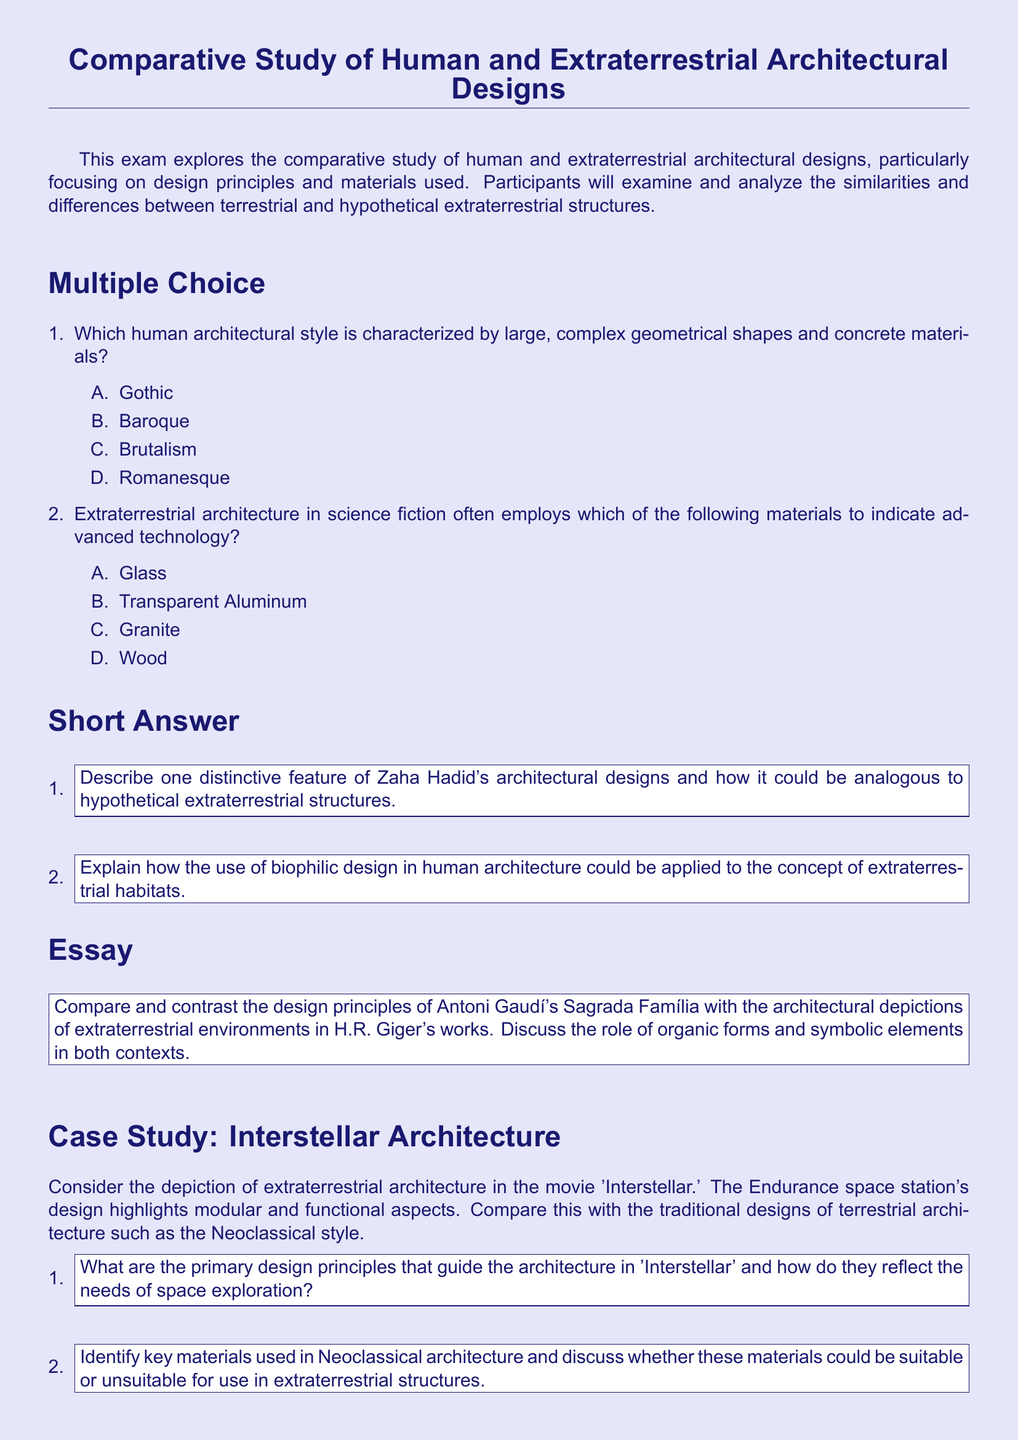What is the main focus of the exam? The exam focuses on the comparative study of human and extraterrestrial architectural designs, particularly on design principles and materials used.
Answer: Comparative study of human and extraterrestrial architectural designs Who is the architect associated with organic forms similar to hypothetical extraterrestrial structures? The distinctive feature of Zaha Hadid's architectural designs aligns with hypothetical extraterrestrial architecture.
Answer: Zaha Hadid What is one material mentioned that represents advanced technology in extraterrestrial architecture? The document lists Transparent Aluminum as a material indicating advanced technology.
Answer: Transparent Aluminum What architectural style is characterized by large geometrical shapes and concrete? The architectural style that features complex geometrical shapes and concrete materials is Brutalism.
Answer: Brutalism In the case study about 'Interstellar,' what design aspect does the Endurance space station highlight? The Endurance space station's design emphasizes modular and functional aspects.
Answer: Modular and functional aspects What are key materials used in Neoclassical architecture that might not be suitable for extraterrestrial structures? The document prompts comparison, hinting at possible unsuitability of traditional materials in extraterrestrial architecture.
Answer: Key materials What is required in the short answer section regarding biophilic design in human architecture? The document asks for an explanation of how biophilic design could be applied to extraterrestrial habitats.
Answer: Application to extraterrestrial habitats How does the exam describe the architectural depictions of extraterrestrial environments? The document prompts comparison with H.R. Giger's works, known for depicting extraterrestrial environments.
Answer: H.R. Giger's works Which human architectural style is mentioned alongside extraterrestrial structures in the essay section? The exam discusses Antoni Gaudí's Sagrada Família in relation to extraterrestrial architectural depictions.
Answer: Antoni Gaudí's Sagrada Família 